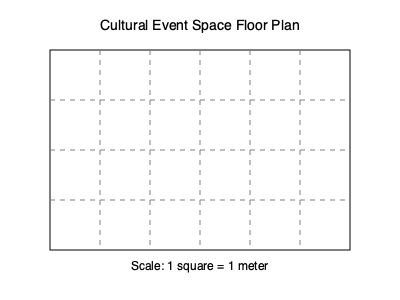As a reporter covering cultural exchange initiatives, you're assessing a new event space for international art exhibitions. Given the floor plan above, estimate the maximum number of people that can comfortably fit in this space, assuming each person requires 1 square meter of personal space. To estimate the number of people that can fit in the cultural event space, we'll follow these steps:

1. Determine the dimensions of the space:
   - The floor plan shows a rectangular space with a grid overlay.
   - Each square represents 1 meter, as indicated by the scale.
   - The space is 6 squares wide and 4 squares long.

2. Calculate the total area:
   - Area = length × width
   - Area = 6 m × 4 m = 24 m²

3. Consider the space requirement per person:
   - Each person requires 1 square meter of personal space.

4. Calculate the maximum number of people:
   - Maximum people = Total area ÷ Space per person
   - Maximum people = 24 m² ÷ 1 m²/person = 24 people

5. Account for practical considerations:
   - In reality, some space would be needed for artworks, circulation, and possibly furniture.
   - A more conservative estimate might reduce the capacity by 20-25%.
   - Adjusted estimate: 24 × 0.75 ≈ 18 people

Therefore, a reasonable estimate for the maximum number of people that can comfortably fit in this cultural event space is 18 people.
Answer: 18 people 